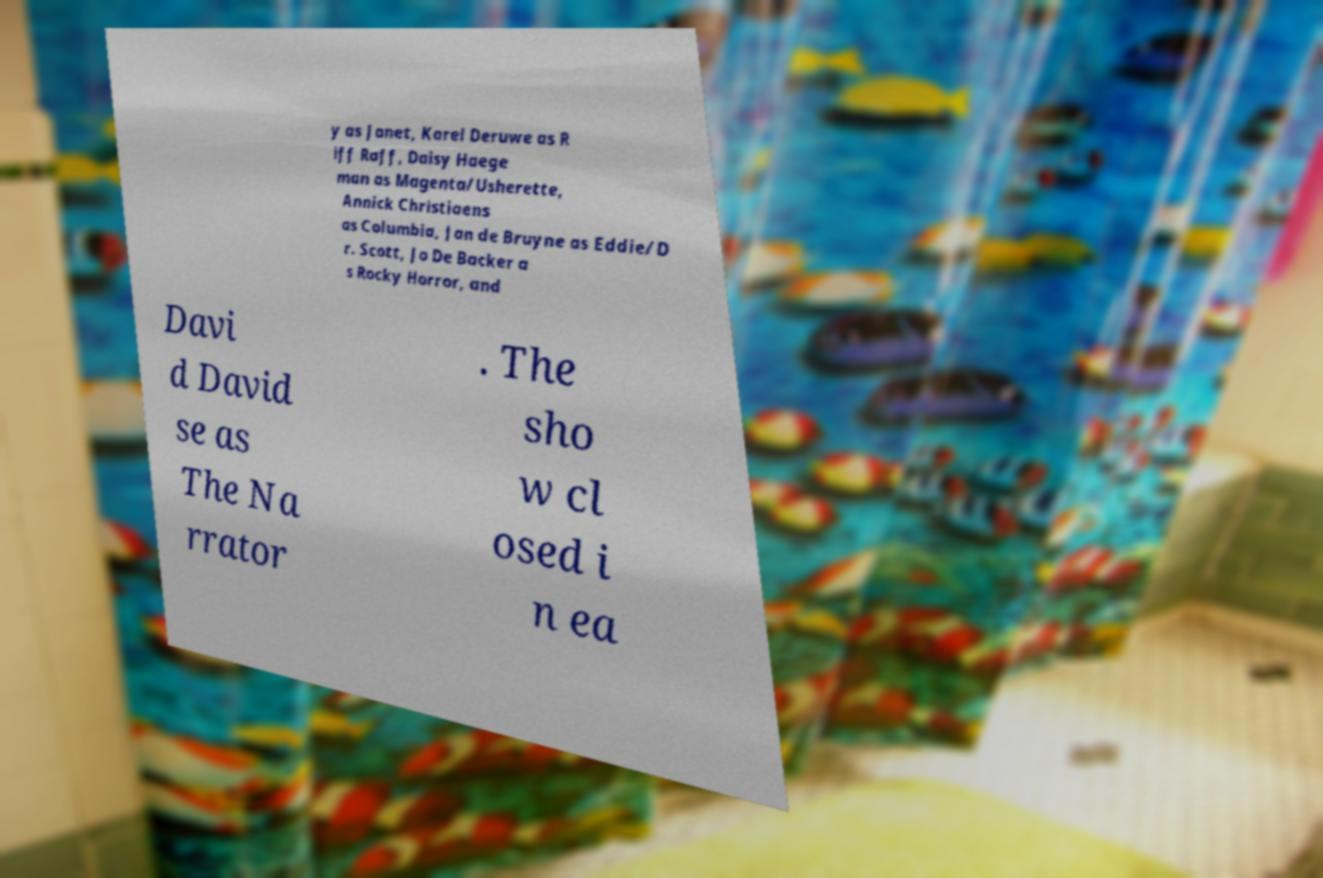There's text embedded in this image that I need extracted. Can you transcribe it verbatim? y as Janet, Karel Deruwe as R iff Raff, Daisy Haege man as Magenta/Usherette, Annick Christiaens as Columbia, Jan de Bruyne as Eddie/D r. Scott, Jo De Backer a s Rocky Horror, and Davi d David se as The Na rrator . The sho w cl osed i n ea 